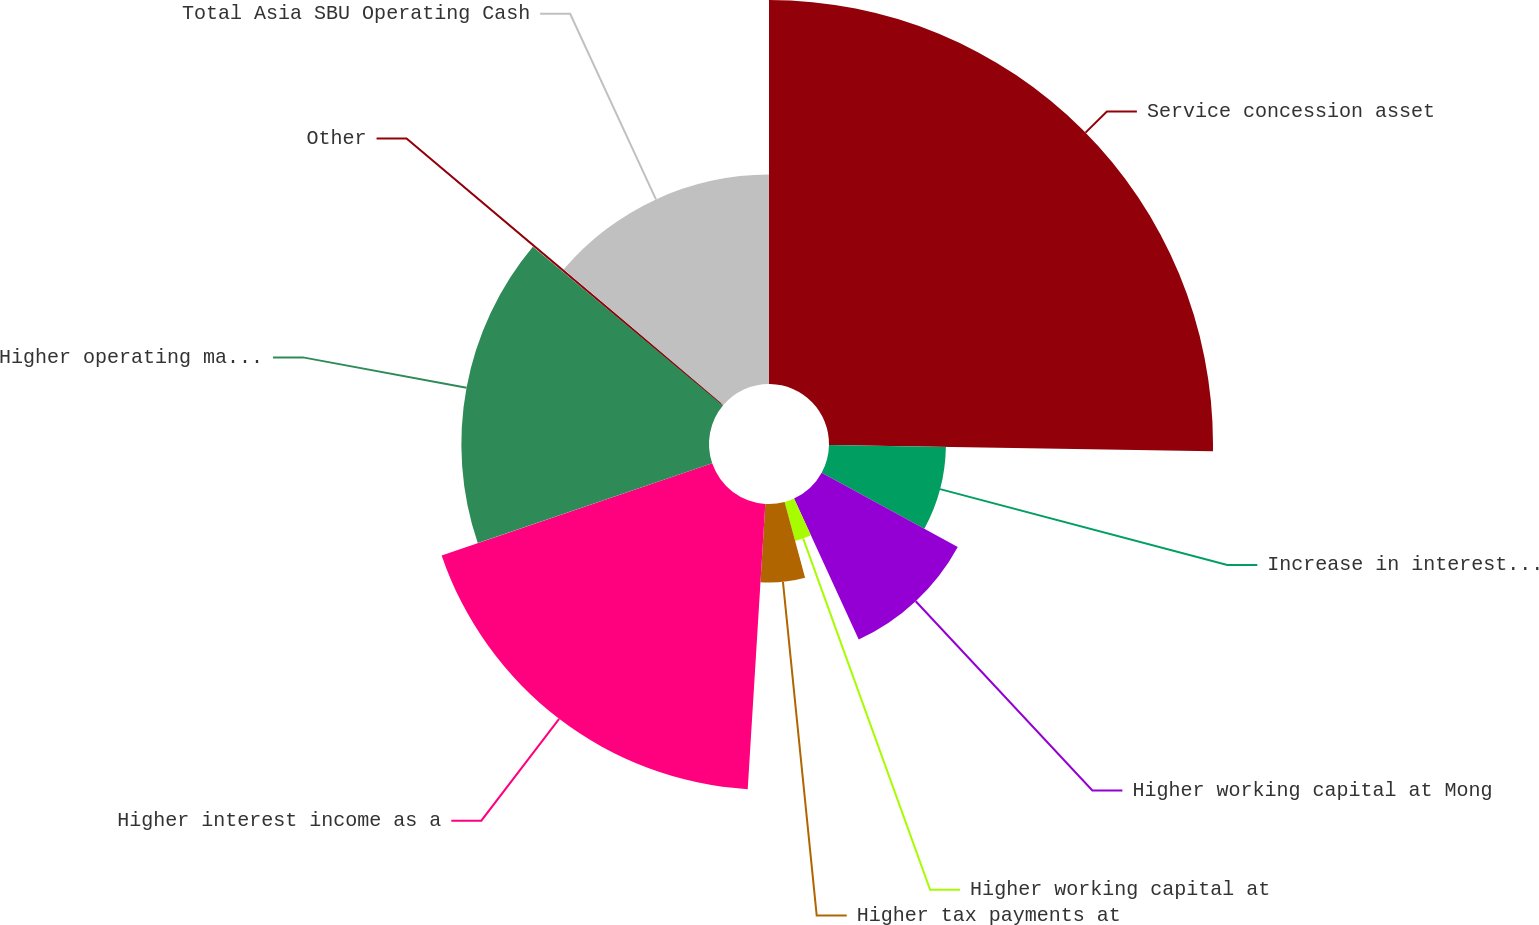Convert chart to OTSL. <chart><loc_0><loc_0><loc_500><loc_500><pie_chart><fcel>Service concession asset<fcel>Increase in interest payments<fcel>Higher working capital at Mong<fcel>Higher working capital at<fcel>Higher tax payments at<fcel>Higher interest income as a<fcel>Higher operating margin net of<fcel>Other<fcel>Total Asia SBU Operating Cash<nl><fcel>25.26%<fcel>7.69%<fcel>10.2%<fcel>2.66%<fcel>5.17%<fcel>18.8%<fcel>16.29%<fcel>0.15%<fcel>13.78%<nl></chart> 